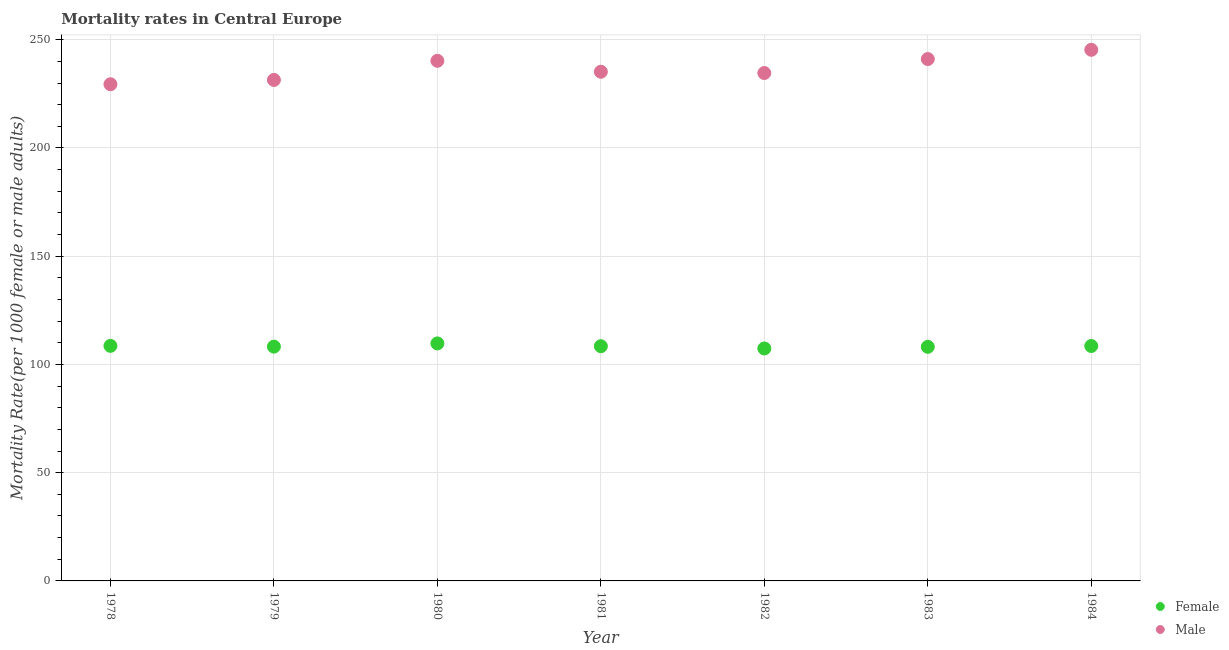What is the male mortality rate in 1979?
Your answer should be very brief. 231.43. Across all years, what is the maximum male mortality rate?
Offer a terse response. 245.35. Across all years, what is the minimum male mortality rate?
Ensure brevity in your answer.  229.44. In which year was the female mortality rate minimum?
Provide a succinct answer. 1982. What is the total male mortality rate in the graph?
Offer a very short reply. 1657.4. What is the difference between the female mortality rate in 1982 and that in 1984?
Provide a succinct answer. -1.14. What is the difference between the male mortality rate in 1982 and the female mortality rate in 1979?
Your response must be concise. 126.39. What is the average male mortality rate per year?
Offer a terse response. 236.77. In the year 1980, what is the difference between the male mortality rate and female mortality rate?
Your response must be concise. 130.55. In how many years, is the female mortality rate greater than 150?
Give a very brief answer. 0. What is the ratio of the male mortality rate in 1978 to that in 1983?
Your response must be concise. 0.95. Is the female mortality rate in 1980 less than that in 1981?
Offer a terse response. No. Is the difference between the female mortality rate in 1978 and 1980 greater than the difference between the male mortality rate in 1978 and 1980?
Provide a short and direct response. Yes. What is the difference between the highest and the second highest female mortality rate?
Make the answer very short. 1.14. What is the difference between the highest and the lowest male mortality rate?
Your answer should be very brief. 15.91. Is the sum of the female mortality rate in 1978 and 1981 greater than the maximum male mortality rate across all years?
Keep it short and to the point. No. Does the male mortality rate monotonically increase over the years?
Make the answer very short. No. Is the male mortality rate strictly greater than the female mortality rate over the years?
Your response must be concise. Yes. Is the male mortality rate strictly less than the female mortality rate over the years?
Your answer should be very brief. No. Does the graph contain grids?
Your answer should be compact. Yes. Where does the legend appear in the graph?
Provide a short and direct response. Bottom right. How many legend labels are there?
Your response must be concise. 2. How are the legend labels stacked?
Your answer should be compact. Vertical. What is the title of the graph?
Provide a short and direct response. Mortality rates in Central Europe. Does "Taxes on exports" appear as one of the legend labels in the graph?
Offer a terse response. No. What is the label or title of the X-axis?
Your answer should be very brief. Year. What is the label or title of the Y-axis?
Your answer should be very brief. Mortality Rate(per 1000 female or male adults). What is the Mortality Rate(per 1000 female or male adults) in Female in 1978?
Make the answer very short. 108.58. What is the Mortality Rate(per 1000 female or male adults) in Male in 1978?
Ensure brevity in your answer.  229.44. What is the Mortality Rate(per 1000 female or male adults) in Female in 1979?
Your response must be concise. 108.23. What is the Mortality Rate(per 1000 female or male adults) of Male in 1979?
Provide a succinct answer. 231.43. What is the Mortality Rate(per 1000 female or male adults) of Female in 1980?
Keep it short and to the point. 109.72. What is the Mortality Rate(per 1000 female or male adults) in Male in 1980?
Give a very brief answer. 240.27. What is the Mortality Rate(per 1000 female or male adults) of Female in 1981?
Your response must be concise. 108.42. What is the Mortality Rate(per 1000 female or male adults) of Male in 1981?
Offer a very short reply. 235.22. What is the Mortality Rate(per 1000 female or male adults) of Female in 1982?
Keep it short and to the point. 107.38. What is the Mortality Rate(per 1000 female or male adults) in Male in 1982?
Make the answer very short. 234.63. What is the Mortality Rate(per 1000 female or male adults) in Female in 1983?
Provide a short and direct response. 108.14. What is the Mortality Rate(per 1000 female or male adults) in Male in 1983?
Your response must be concise. 241.08. What is the Mortality Rate(per 1000 female or male adults) in Female in 1984?
Provide a succinct answer. 108.52. What is the Mortality Rate(per 1000 female or male adults) in Male in 1984?
Your response must be concise. 245.35. Across all years, what is the maximum Mortality Rate(per 1000 female or male adults) of Female?
Offer a very short reply. 109.72. Across all years, what is the maximum Mortality Rate(per 1000 female or male adults) of Male?
Provide a succinct answer. 245.35. Across all years, what is the minimum Mortality Rate(per 1000 female or male adults) in Female?
Offer a very short reply. 107.38. Across all years, what is the minimum Mortality Rate(per 1000 female or male adults) of Male?
Offer a very short reply. 229.44. What is the total Mortality Rate(per 1000 female or male adults) in Female in the graph?
Offer a very short reply. 758.99. What is the total Mortality Rate(per 1000 female or male adults) of Male in the graph?
Make the answer very short. 1657.4. What is the difference between the Mortality Rate(per 1000 female or male adults) in Female in 1978 and that in 1979?
Your response must be concise. 0.35. What is the difference between the Mortality Rate(per 1000 female or male adults) in Male in 1978 and that in 1979?
Keep it short and to the point. -2. What is the difference between the Mortality Rate(per 1000 female or male adults) of Female in 1978 and that in 1980?
Keep it short and to the point. -1.14. What is the difference between the Mortality Rate(per 1000 female or male adults) of Male in 1978 and that in 1980?
Give a very brief answer. -10.83. What is the difference between the Mortality Rate(per 1000 female or male adults) of Female in 1978 and that in 1981?
Keep it short and to the point. 0.16. What is the difference between the Mortality Rate(per 1000 female or male adults) of Male in 1978 and that in 1981?
Give a very brief answer. -5.78. What is the difference between the Mortality Rate(per 1000 female or male adults) in Female in 1978 and that in 1982?
Give a very brief answer. 1.2. What is the difference between the Mortality Rate(per 1000 female or male adults) of Male in 1978 and that in 1982?
Make the answer very short. -5.19. What is the difference between the Mortality Rate(per 1000 female or male adults) of Female in 1978 and that in 1983?
Provide a succinct answer. 0.44. What is the difference between the Mortality Rate(per 1000 female or male adults) of Male in 1978 and that in 1983?
Ensure brevity in your answer.  -11.64. What is the difference between the Mortality Rate(per 1000 female or male adults) in Female in 1978 and that in 1984?
Your response must be concise. 0.06. What is the difference between the Mortality Rate(per 1000 female or male adults) in Male in 1978 and that in 1984?
Provide a short and direct response. -15.91. What is the difference between the Mortality Rate(per 1000 female or male adults) in Female in 1979 and that in 1980?
Your answer should be very brief. -1.48. What is the difference between the Mortality Rate(per 1000 female or male adults) of Male in 1979 and that in 1980?
Keep it short and to the point. -8.83. What is the difference between the Mortality Rate(per 1000 female or male adults) of Female in 1979 and that in 1981?
Provide a succinct answer. -0.19. What is the difference between the Mortality Rate(per 1000 female or male adults) in Male in 1979 and that in 1981?
Ensure brevity in your answer.  -3.79. What is the difference between the Mortality Rate(per 1000 female or male adults) of Female in 1979 and that in 1982?
Ensure brevity in your answer.  0.85. What is the difference between the Mortality Rate(per 1000 female or male adults) in Male in 1979 and that in 1982?
Ensure brevity in your answer.  -3.19. What is the difference between the Mortality Rate(per 1000 female or male adults) of Female in 1979 and that in 1983?
Ensure brevity in your answer.  0.09. What is the difference between the Mortality Rate(per 1000 female or male adults) of Male in 1979 and that in 1983?
Offer a terse response. -9.65. What is the difference between the Mortality Rate(per 1000 female or male adults) in Female in 1979 and that in 1984?
Offer a terse response. -0.29. What is the difference between the Mortality Rate(per 1000 female or male adults) in Male in 1979 and that in 1984?
Keep it short and to the point. -13.92. What is the difference between the Mortality Rate(per 1000 female or male adults) of Female in 1980 and that in 1981?
Give a very brief answer. 1.29. What is the difference between the Mortality Rate(per 1000 female or male adults) in Male in 1980 and that in 1981?
Give a very brief answer. 5.05. What is the difference between the Mortality Rate(per 1000 female or male adults) of Female in 1980 and that in 1982?
Provide a short and direct response. 2.33. What is the difference between the Mortality Rate(per 1000 female or male adults) of Male in 1980 and that in 1982?
Ensure brevity in your answer.  5.64. What is the difference between the Mortality Rate(per 1000 female or male adults) in Female in 1980 and that in 1983?
Offer a very short reply. 1.58. What is the difference between the Mortality Rate(per 1000 female or male adults) in Male in 1980 and that in 1983?
Your answer should be compact. -0.81. What is the difference between the Mortality Rate(per 1000 female or male adults) in Female in 1980 and that in 1984?
Provide a short and direct response. 1.2. What is the difference between the Mortality Rate(per 1000 female or male adults) in Male in 1980 and that in 1984?
Keep it short and to the point. -5.08. What is the difference between the Mortality Rate(per 1000 female or male adults) of Female in 1981 and that in 1982?
Your answer should be very brief. 1.04. What is the difference between the Mortality Rate(per 1000 female or male adults) in Male in 1981 and that in 1982?
Your answer should be compact. 0.59. What is the difference between the Mortality Rate(per 1000 female or male adults) of Female in 1981 and that in 1983?
Make the answer very short. 0.28. What is the difference between the Mortality Rate(per 1000 female or male adults) in Male in 1981 and that in 1983?
Make the answer very short. -5.86. What is the difference between the Mortality Rate(per 1000 female or male adults) in Female in 1981 and that in 1984?
Ensure brevity in your answer.  -0.09. What is the difference between the Mortality Rate(per 1000 female or male adults) in Male in 1981 and that in 1984?
Your answer should be very brief. -10.13. What is the difference between the Mortality Rate(per 1000 female or male adults) in Female in 1982 and that in 1983?
Provide a succinct answer. -0.76. What is the difference between the Mortality Rate(per 1000 female or male adults) in Male in 1982 and that in 1983?
Provide a succinct answer. -6.45. What is the difference between the Mortality Rate(per 1000 female or male adults) of Female in 1982 and that in 1984?
Your answer should be very brief. -1.14. What is the difference between the Mortality Rate(per 1000 female or male adults) of Male in 1982 and that in 1984?
Give a very brief answer. -10.72. What is the difference between the Mortality Rate(per 1000 female or male adults) of Female in 1983 and that in 1984?
Offer a terse response. -0.38. What is the difference between the Mortality Rate(per 1000 female or male adults) in Male in 1983 and that in 1984?
Your response must be concise. -4.27. What is the difference between the Mortality Rate(per 1000 female or male adults) in Female in 1978 and the Mortality Rate(per 1000 female or male adults) in Male in 1979?
Provide a short and direct response. -122.85. What is the difference between the Mortality Rate(per 1000 female or male adults) of Female in 1978 and the Mortality Rate(per 1000 female or male adults) of Male in 1980?
Give a very brief answer. -131.69. What is the difference between the Mortality Rate(per 1000 female or male adults) in Female in 1978 and the Mortality Rate(per 1000 female or male adults) in Male in 1981?
Ensure brevity in your answer.  -126.64. What is the difference between the Mortality Rate(per 1000 female or male adults) in Female in 1978 and the Mortality Rate(per 1000 female or male adults) in Male in 1982?
Keep it short and to the point. -126.05. What is the difference between the Mortality Rate(per 1000 female or male adults) in Female in 1978 and the Mortality Rate(per 1000 female or male adults) in Male in 1983?
Give a very brief answer. -132.5. What is the difference between the Mortality Rate(per 1000 female or male adults) in Female in 1978 and the Mortality Rate(per 1000 female or male adults) in Male in 1984?
Offer a very short reply. -136.77. What is the difference between the Mortality Rate(per 1000 female or male adults) in Female in 1979 and the Mortality Rate(per 1000 female or male adults) in Male in 1980?
Offer a terse response. -132.03. What is the difference between the Mortality Rate(per 1000 female or male adults) of Female in 1979 and the Mortality Rate(per 1000 female or male adults) of Male in 1981?
Make the answer very short. -126.98. What is the difference between the Mortality Rate(per 1000 female or male adults) of Female in 1979 and the Mortality Rate(per 1000 female or male adults) of Male in 1982?
Make the answer very short. -126.39. What is the difference between the Mortality Rate(per 1000 female or male adults) of Female in 1979 and the Mortality Rate(per 1000 female or male adults) of Male in 1983?
Provide a succinct answer. -132.85. What is the difference between the Mortality Rate(per 1000 female or male adults) in Female in 1979 and the Mortality Rate(per 1000 female or male adults) in Male in 1984?
Offer a very short reply. -137.11. What is the difference between the Mortality Rate(per 1000 female or male adults) in Female in 1980 and the Mortality Rate(per 1000 female or male adults) in Male in 1981?
Give a very brief answer. -125.5. What is the difference between the Mortality Rate(per 1000 female or male adults) in Female in 1980 and the Mortality Rate(per 1000 female or male adults) in Male in 1982?
Provide a succinct answer. -124.91. What is the difference between the Mortality Rate(per 1000 female or male adults) of Female in 1980 and the Mortality Rate(per 1000 female or male adults) of Male in 1983?
Make the answer very short. -131.36. What is the difference between the Mortality Rate(per 1000 female or male adults) in Female in 1980 and the Mortality Rate(per 1000 female or male adults) in Male in 1984?
Make the answer very short. -135.63. What is the difference between the Mortality Rate(per 1000 female or male adults) in Female in 1981 and the Mortality Rate(per 1000 female or male adults) in Male in 1982?
Provide a short and direct response. -126.2. What is the difference between the Mortality Rate(per 1000 female or male adults) of Female in 1981 and the Mortality Rate(per 1000 female or male adults) of Male in 1983?
Ensure brevity in your answer.  -132.66. What is the difference between the Mortality Rate(per 1000 female or male adults) in Female in 1981 and the Mortality Rate(per 1000 female or male adults) in Male in 1984?
Make the answer very short. -136.92. What is the difference between the Mortality Rate(per 1000 female or male adults) in Female in 1982 and the Mortality Rate(per 1000 female or male adults) in Male in 1983?
Ensure brevity in your answer.  -133.7. What is the difference between the Mortality Rate(per 1000 female or male adults) in Female in 1982 and the Mortality Rate(per 1000 female or male adults) in Male in 1984?
Offer a terse response. -137.97. What is the difference between the Mortality Rate(per 1000 female or male adults) in Female in 1983 and the Mortality Rate(per 1000 female or male adults) in Male in 1984?
Provide a succinct answer. -137.21. What is the average Mortality Rate(per 1000 female or male adults) of Female per year?
Ensure brevity in your answer.  108.43. What is the average Mortality Rate(per 1000 female or male adults) in Male per year?
Keep it short and to the point. 236.77. In the year 1978, what is the difference between the Mortality Rate(per 1000 female or male adults) in Female and Mortality Rate(per 1000 female or male adults) in Male?
Provide a short and direct response. -120.86. In the year 1979, what is the difference between the Mortality Rate(per 1000 female or male adults) in Female and Mortality Rate(per 1000 female or male adults) in Male?
Provide a succinct answer. -123.2. In the year 1980, what is the difference between the Mortality Rate(per 1000 female or male adults) in Female and Mortality Rate(per 1000 female or male adults) in Male?
Keep it short and to the point. -130.55. In the year 1981, what is the difference between the Mortality Rate(per 1000 female or male adults) in Female and Mortality Rate(per 1000 female or male adults) in Male?
Ensure brevity in your answer.  -126.79. In the year 1982, what is the difference between the Mortality Rate(per 1000 female or male adults) of Female and Mortality Rate(per 1000 female or male adults) of Male?
Give a very brief answer. -127.24. In the year 1983, what is the difference between the Mortality Rate(per 1000 female or male adults) of Female and Mortality Rate(per 1000 female or male adults) of Male?
Ensure brevity in your answer.  -132.94. In the year 1984, what is the difference between the Mortality Rate(per 1000 female or male adults) of Female and Mortality Rate(per 1000 female or male adults) of Male?
Give a very brief answer. -136.83. What is the ratio of the Mortality Rate(per 1000 female or male adults) in Female in 1978 to that in 1979?
Provide a short and direct response. 1. What is the ratio of the Mortality Rate(per 1000 female or male adults) of Male in 1978 to that in 1979?
Ensure brevity in your answer.  0.99. What is the ratio of the Mortality Rate(per 1000 female or male adults) in Female in 1978 to that in 1980?
Your answer should be very brief. 0.99. What is the ratio of the Mortality Rate(per 1000 female or male adults) of Male in 1978 to that in 1980?
Keep it short and to the point. 0.95. What is the ratio of the Mortality Rate(per 1000 female or male adults) in Female in 1978 to that in 1981?
Give a very brief answer. 1. What is the ratio of the Mortality Rate(per 1000 female or male adults) of Male in 1978 to that in 1981?
Your answer should be very brief. 0.98. What is the ratio of the Mortality Rate(per 1000 female or male adults) in Female in 1978 to that in 1982?
Your response must be concise. 1.01. What is the ratio of the Mortality Rate(per 1000 female or male adults) of Male in 1978 to that in 1982?
Offer a very short reply. 0.98. What is the ratio of the Mortality Rate(per 1000 female or male adults) of Male in 1978 to that in 1983?
Your response must be concise. 0.95. What is the ratio of the Mortality Rate(per 1000 female or male adults) in Male in 1978 to that in 1984?
Your answer should be compact. 0.94. What is the ratio of the Mortality Rate(per 1000 female or male adults) in Female in 1979 to that in 1980?
Provide a short and direct response. 0.99. What is the ratio of the Mortality Rate(per 1000 female or male adults) of Male in 1979 to that in 1980?
Your answer should be compact. 0.96. What is the ratio of the Mortality Rate(per 1000 female or male adults) in Male in 1979 to that in 1981?
Ensure brevity in your answer.  0.98. What is the ratio of the Mortality Rate(per 1000 female or male adults) in Female in 1979 to that in 1982?
Provide a succinct answer. 1.01. What is the ratio of the Mortality Rate(per 1000 female or male adults) of Male in 1979 to that in 1982?
Offer a very short reply. 0.99. What is the ratio of the Mortality Rate(per 1000 female or male adults) in Male in 1979 to that in 1983?
Your answer should be compact. 0.96. What is the ratio of the Mortality Rate(per 1000 female or male adults) of Female in 1979 to that in 1984?
Make the answer very short. 1. What is the ratio of the Mortality Rate(per 1000 female or male adults) of Male in 1979 to that in 1984?
Offer a terse response. 0.94. What is the ratio of the Mortality Rate(per 1000 female or male adults) in Female in 1980 to that in 1981?
Your answer should be very brief. 1.01. What is the ratio of the Mortality Rate(per 1000 female or male adults) in Male in 1980 to that in 1981?
Offer a terse response. 1.02. What is the ratio of the Mortality Rate(per 1000 female or male adults) in Female in 1980 to that in 1982?
Provide a short and direct response. 1.02. What is the ratio of the Mortality Rate(per 1000 female or male adults) in Female in 1980 to that in 1983?
Give a very brief answer. 1.01. What is the ratio of the Mortality Rate(per 1000 female or male adults) of Female in 1980 to that in 1984?
Give a very brief answer. 1.01. What is the ratio of the Mortality Rate(per 1000 female or male adults) in Male in 1980 to that in 1984?
Your answer should be very brief. 0.98. What is the ratio of the Mortality Rate(per 1000 female or male adults) of Female in 1981 to that in 1982?
Provide a succinct answer. 1.01. What is the ratio of the Mortality Rate(per 1000 female or male adults) in Male in 1981 to that in 1982?
Offer a terse response. 1. What is the ratio of the Mortality Rate(per 1000 female or male adults) in Female in 1981 to that in 1983?
Make the answer very short. 1. What is the ratio of the Mortality Rate(per 1000 female or male adults) in Male in 1981 to that in 1983?
Give a very brief answer. 0.98. What is the ratio of the Mortality Rate(per 1000 female or male adults) in Male in 1981 to that in 1984?
Give a very brief answer. 0.96. What is the ratio of the Mortality Rate(per 1000 female or male adults) of Male in 1982 to that in 1983?
Offer a terse response. 0.97. What is the ratio of the Mortality Rate(per 1000 female or male adults) in Female in 1982 to that in 1984?
Give a very brief answer. 0.99. What is the ratio of the Mortality Rate(per 1000 female or male adults) in Male in 1982 to that in 1984?
Your answer should be compact. 0.96. What is the ratio of the Mortality Rate(per 1000 female or male adults) in Female in 1983 to that in 1984?
Your answer should be compact. 1. What is the ratio of the Mortality Rate(per 1000 female or male adults) in Male in 1983 to that in 1984?
Give a very brief answer. 0.98. What is the difference between the highest and the second highest Mortality Rate(per 1000 female or male adults) in Female?
Offer a terse response. 1.14. What is the difference between the highest and the second highest Mortality Rate(per 1000 female or male adults) of Male?
Offer a terse response. 4.27. What is the difference between the highest and the lowest Mortality Rate(per 1000 female or male adults) in Female?
Provide a short and direct response. 2.33. What is the difference between the highest and the lowest Mortality Rate(per 1000 female or male adults) in Male?
Provide a succinct answer. 15.91. 